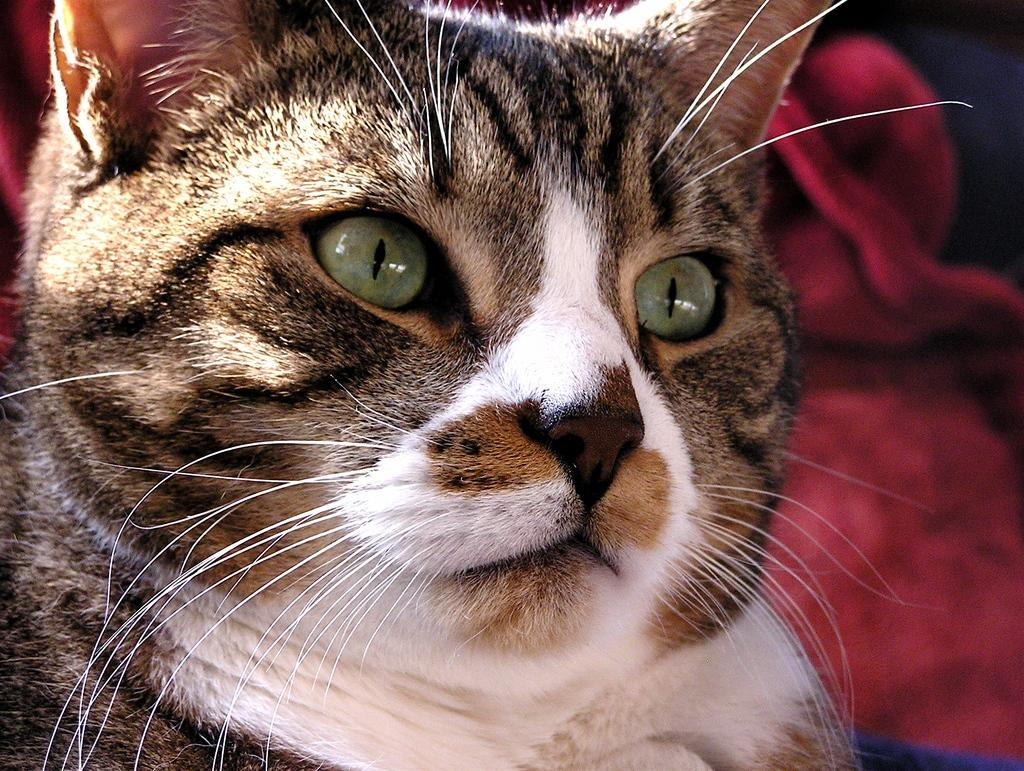What animal can be seen in the picture? There is a cat in the picture. Where is the cat located in the image? The cat is sitting on a couch. What color is the cloth beside the cat? The cloth beside the cat is red. What type of haircut does the cat have in the image? There is no indication of a haircut in the image, as cats do not have hair that can be cut like humans. 